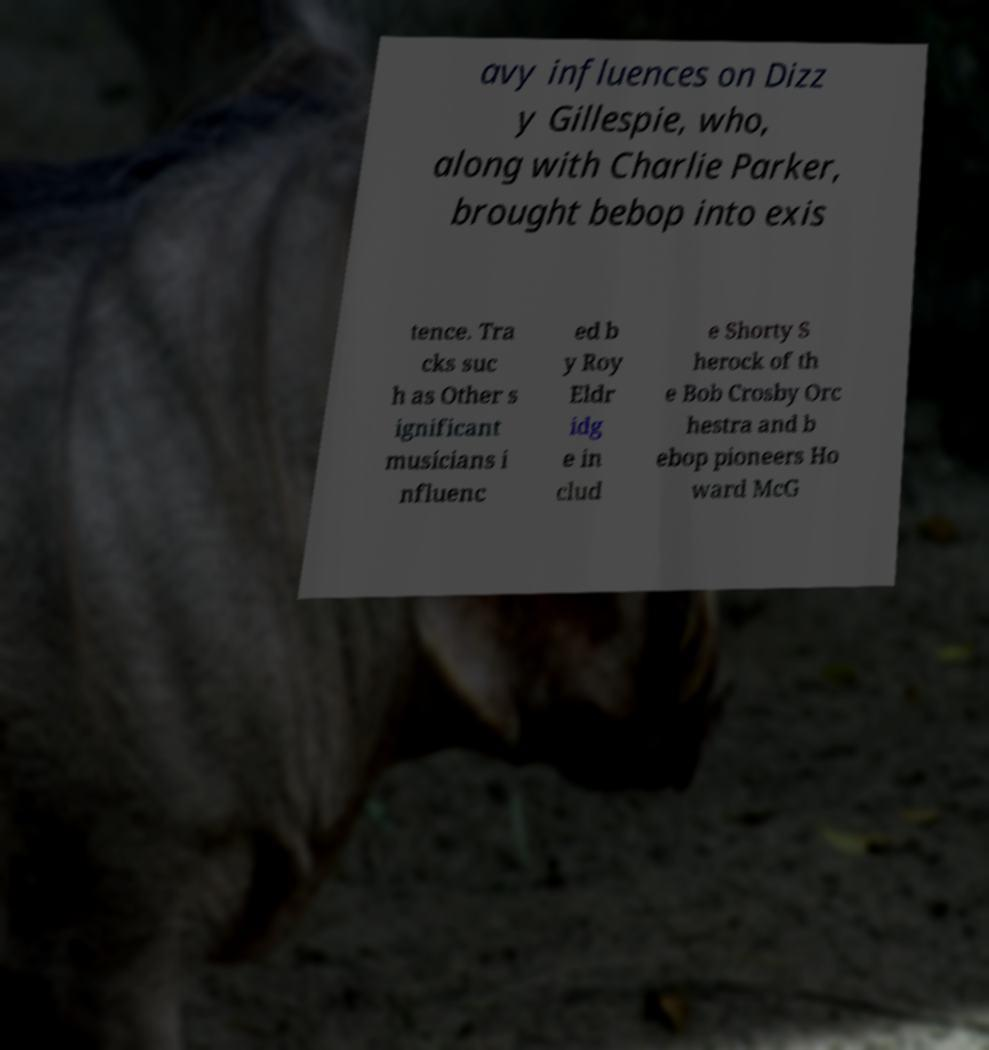There's text embedded in this image that I need extracted. Can you transcribe it verbatim? avy influences on Dizz y Gillespie, who, along with Charlie Parker, brought bebop into exis tence. Tra cks suc h as Other s ignificant musicians i nfluenc ed b y Roy Eldr idg e in clud e Shorty S herock of th e Bob Crosby Orc hestra and b ebop pioneers Ho ward McG 